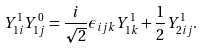<formula> <loc_0><loc_0><loc_500><loc_500>Y _ { 1 i } ^ { 1 } Y _ { 1 j } ^ { 0 } = \frac { i } { \sqrt { 2 } } \epsilon _ { i j k } Y _ { 1 k } ^ { 1 } + \frac { 1 } { 2 } Y _ { 2 i j } ^ { 1 } .</formula> 